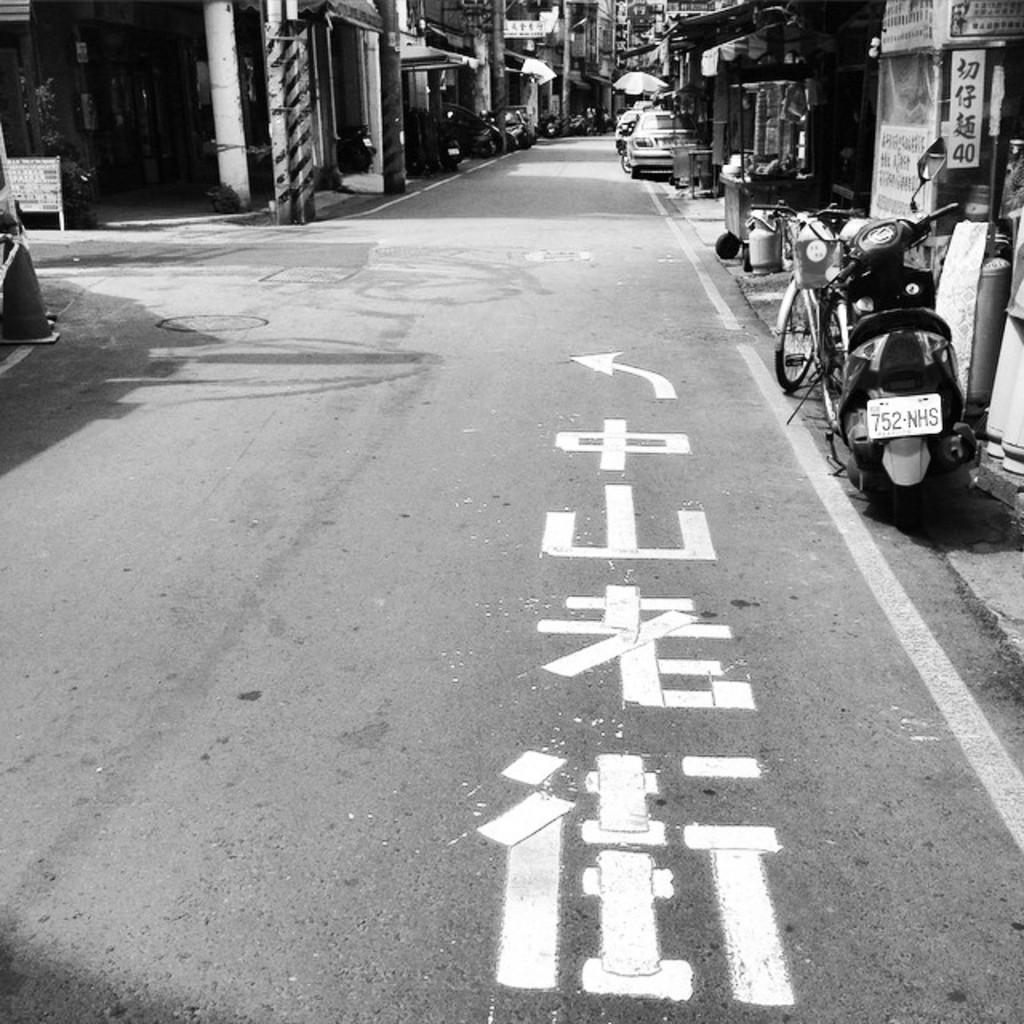Can you describe this image briefly? It is the road, on the right side a vehicle is parked, these are the houses. 